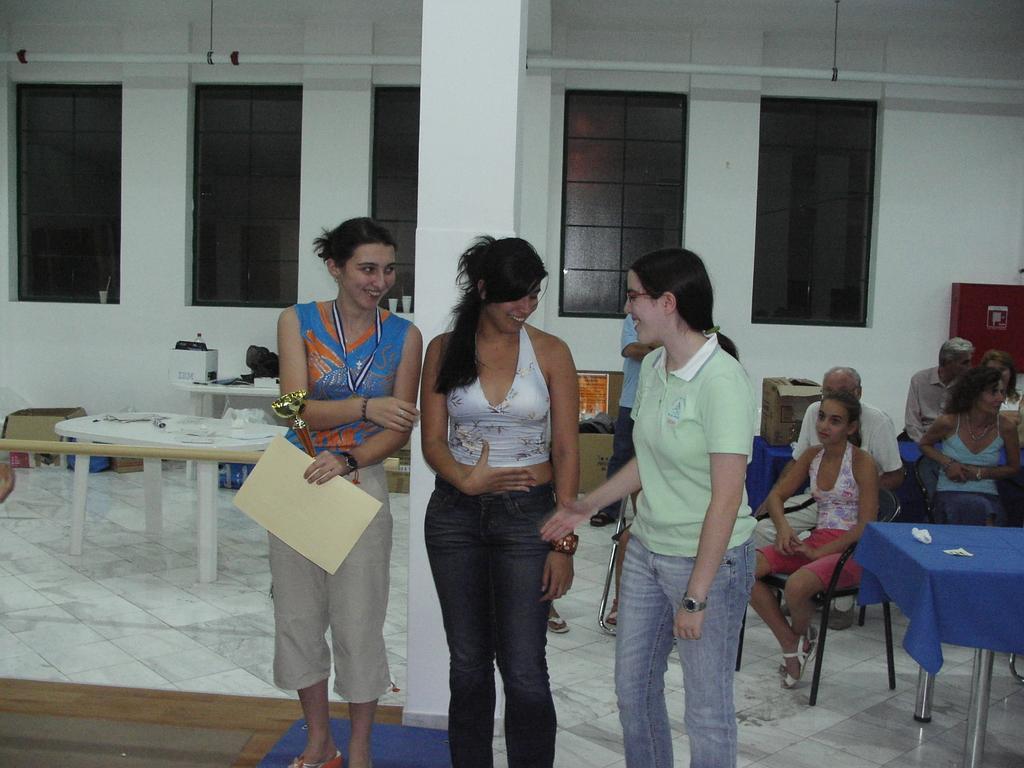Can you describe this image briefly? This picture describes about group of people, some people are seated on the chair and some are standing. In the left side of the image a woman holding a paper and a shield and also we can see some boxes on the table. 